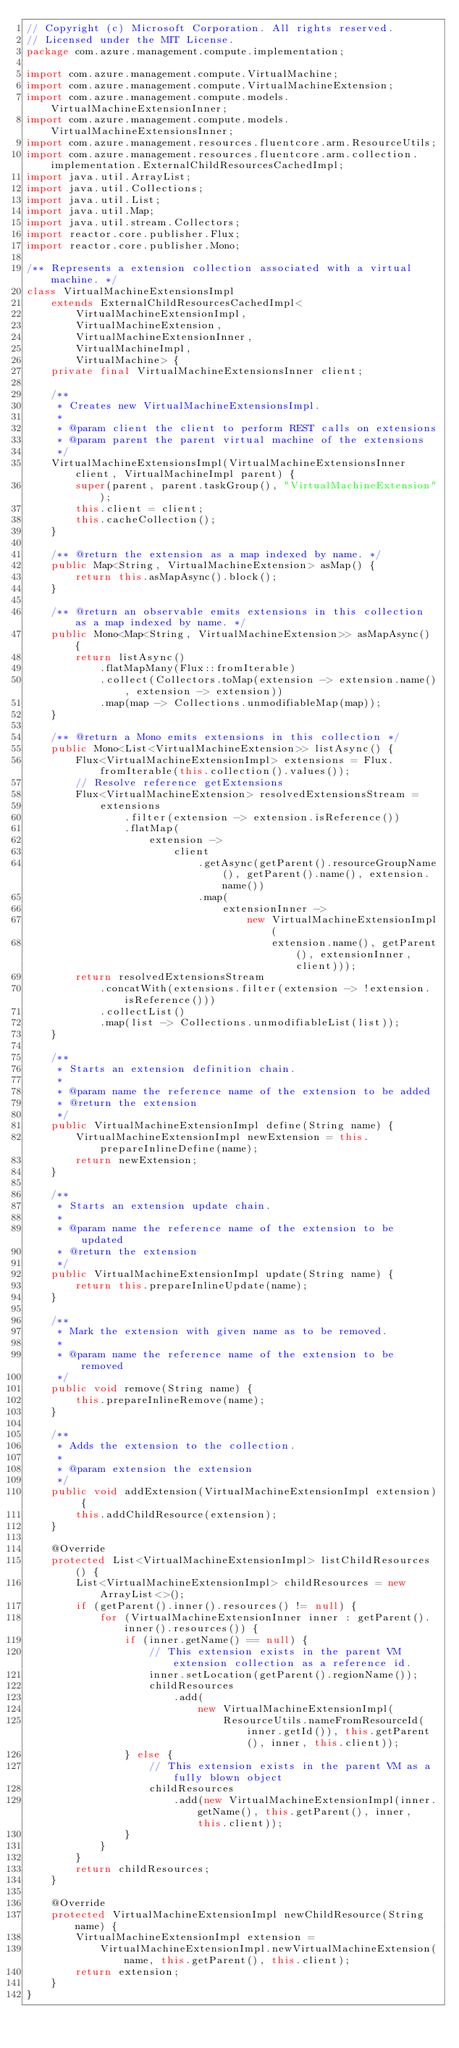<code> <loc_0><loc_0><loc_500><loc_500><_Java_>// Copyright (c) Microsoft Corporation. All rights reserved.
// Licensed under the MIT License.
package com.azure.management.compute.implementation;

import com.azure.management.compute.VirtualMachine;
import com.azure.management.compute.VirtualMachineExtension;
import com.azure.management.compute.models.VirtualMachineExtensionInner;
import com.azure.management.compute.models.VirtualMachineExtensionsInner;
import com.azure.management.resources.fluentcore.arm.ResourceUtils;
import com.azure.management.resources.fluentcore.arm.collection.implementation.ExternalChildResourcesCachedImpl;
import java.util.ArrayList;
import java.util.Collections;
import java.util.List;
import java.util.Map;
import java.util.stream.Collectors;
import reactor.core.publisher.Flux;
import reactor.core.publisher.Mono;

/** Represents a extension collection associated with a virtual machine. */
class VirtualMachineExtensionsImpl
    extends ExternalChildResourcesCachedImpl<
        VirtualMachineExtensionImpl,
        VirtualMachineExtension,
        VirtualMachineExtensionInner,
        VirtualMachineImpl,
        VirtualMachine> {
    private final VirtualMachineExtensionsInner client;

    /**
     * Creates new VirtualMachineExtensionsImpl.
     *
     * @param client the client to perform REST calls on extensions
     * @param parent the parent virtual machine of the extensions
     */
    VirtualMachineExtensionsImpl(VirtualMachineExtensionsInner client, VirtualMachineImpl parent) {
        super(parent, parent.taskGroup(), "VirtualMachineExtension");
        this.client = client;
        this.cacheCollection();
    }

    /** @return the extension as a map indexed by name. */
    public Map<String, VirtualMachineExtension> asMap() {
        return this.asMapAsync().block();
    }

    /** @return an observable emits extensions in this collection as a map indexed by name. */
    public Mono<Map<String, VirtualMachineExtension>> asMapAsync() {
        return listAsync()
            .flatMapMany(Flux::fromIterable)
            .collect(Collectors.toMap(extension -> extension.name(), extension -> extension))
            .map(map -> Collections.unmodifiableMap(map));
    }

    /** @return a Mono emits extensions in this collection */
    public Mono<List<VirtualMachineExtension>> listAsync() {
        Flux<VirtualMachineExtensionImpl> extensions = Flux.fromIterable(this.collection().values());
        // Resolve reference getExtensions
        Flux<VirtualMachineExtension> resolvedExtensionsStream =
            extensions
                .filter(extension -> extension.isReference())
                .flatMap(
                    extension ->
                        client
                            .getAsync(getParent().resourceGroupName(), getParent().name(), extension.name())
                            .map(
                                extensionInner ->
                                    new VirtualMachineExtensionImpl(
                                        extension.name(), getParent(), extensionInner, client)));
        return resolvedExtensionsStream
            .concatWith(extensions.filter(extension -> !extension.isReference()))
            .collectList()
            .map(list -> Collections.unmodifiableList(list));
    }

    /**
     * Starts an extension definition chain.
     *
     * @param name the reference name of the extension to be added
     * @return the extension
     */
    public VirtualMachineExtensionImpl define(String name) {
        VirtualMachineExtensionImpl newExtension = this.prepareInlineDefine(name);
        return newExtension;
    }

    /**
     * Starts an extension update chain.
     *
     * @param name the reference name of the extension to be updated
     * @return the extension
     */
    public VirtualMachineExtensionImpl update(String name) {
        return this.prepareInlineUpdate(name);
    }

    /**
     * Mark the extension with given name as to be removed.
     *
     * @param name the reference name of the extension to be removed
     */
    public void remove(String name) {
        this.prepareInlineRemove(name);
    }

    /**
     * Adds the extension to the collection.
     *
     * @param extension the extension
     */
    public void addExtension(VirtualMachineExtensionImpl extension) {
        this.addChildResource(extension);
    }

    @Override
    protected List<VirtualMachineExtensionImpl> listChildResources() {
        List<VirtualMachineExtensionImpl> childResources = new ArrayList<>();
        if (getParent().inner().resources() != null) {
            for (VirtualMachineExtensionInner inner : getParent().inner().resources()) {
                if (inner.getName() == null) {
                    // This extension exists in the parent VM extension collection as a reference id.
                    inner.setLocation(getParent().regionName());
                    childResources
                        .add(
                            new VirtualMachineExtensionImpl(
                                ResourceUtils.nameFromResourceId(inner.getId()), this.getParent(), inner, this.client));
                } else {
                    // This extension exists in the parent VM as a fully blown object
                    childResources
                        .add(new VirtualMachineExtensionImpl(inner.getName(), this.getParent(), inner, this.client));
                }
            }
        }
        return childResources;
    }

    @Override
    protected VirtualMachineExtensionImpl newChildResource(String name) {
        VirtualMachineExtensionImpl extension =
            VirtualMachineExtensionImpl.newVirtualMachineExtension(name, this.getParent(), this.client);
        return extension;
    }
}
</code> 